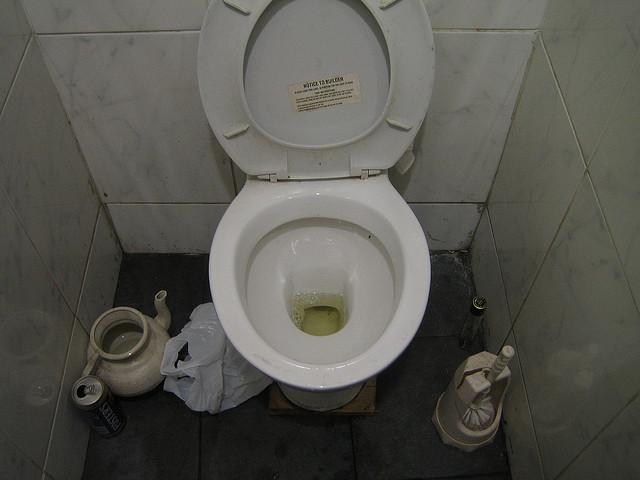Is the toilet clean?
Quick response, please. No. Is that a beer can?
Keep it brief. Yes. Is the bathroom clean?
Give a very brief answer. No. What is found on the floor of the bathroom?
Give a very brief answer. Toilet brush pot soda can. Is the toilet clean or dirty?
Answer briefly. Dirty. Is this bathroom clean?
Concise answer only. No. 